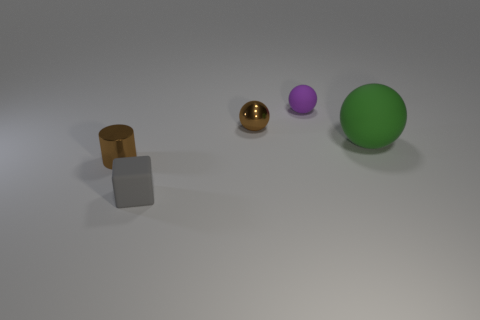What is the shape of the tiny thing that is the same color as the metal ball?
Keep it short and to the point. Cylinder. There is a small brown thing on the left side of the gray rubber object; what material is it?
Your answer should be very brief. Metal. How many brown things have the same shape as the green object?
Ensure brevity in your answer.  1. What is the shape of the tiny purple object that is the same material as the large green thing?
Your answer should be very brief. Sphere. What shape is the small thing that is in front of the brown shiny thing that is in front of the tiny brown metallic thing that is to the right of the tiny cube?
Ensure brevity in your answer.  Cube. Is the number of purple rubber objects greater than the number of tiny shiny things?
Your response must be concise. No. There is a small purple object that is the same shape as the green rubber object; what is it made of?
Provide a succinct answer. Rubber. Are the small brown cylinder and the small gray cube made of the same material?
Your answer should be very brief. No. Are there more balls that are in front of the green ball than tiny gray balls?
Keep it short and to the point. No. There is a thing right of the matte sphere to the left of the object to the right of the small rubber sphere; what is it made of?
Provide a succinct answer. Rubber. 